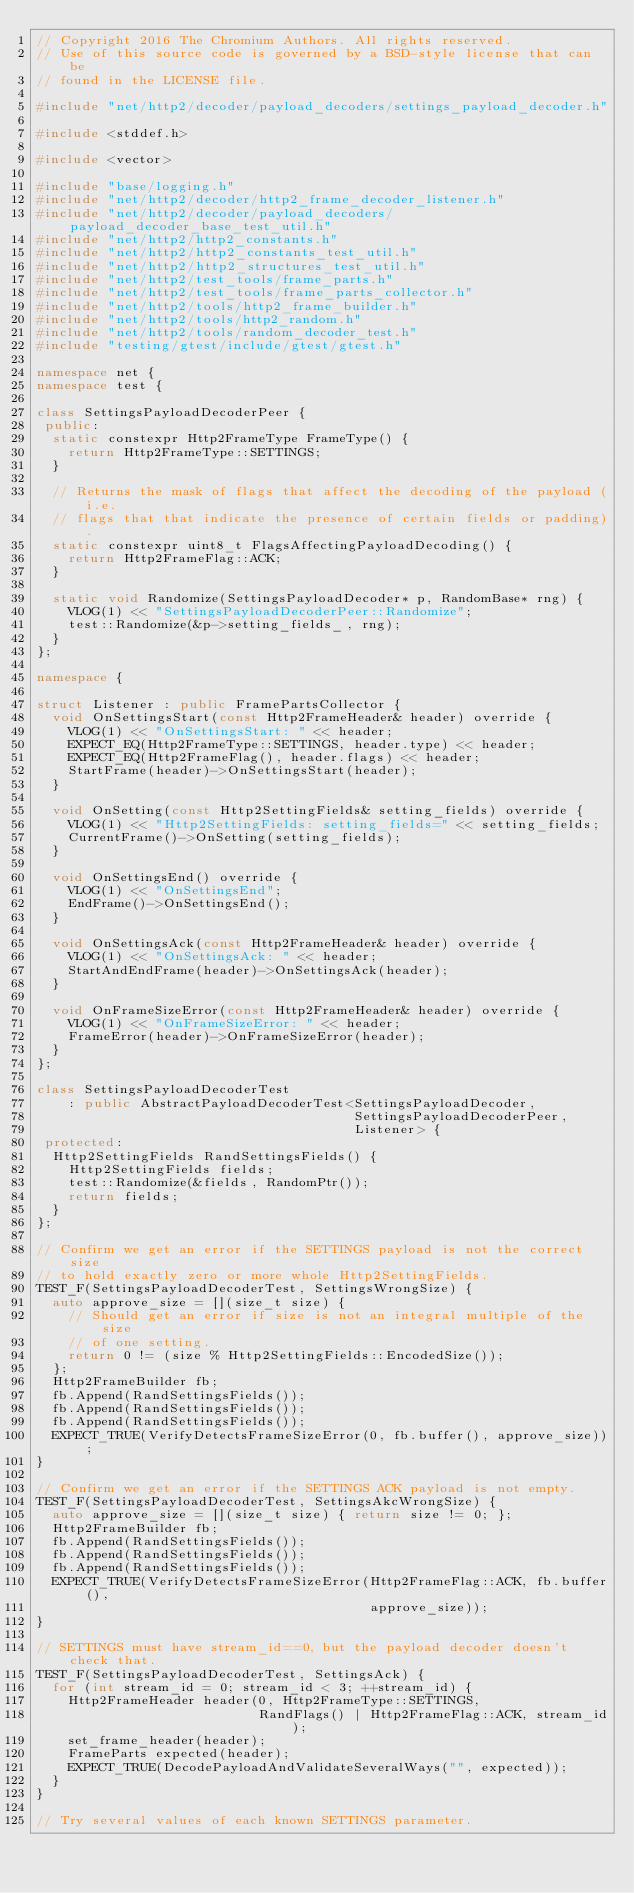<code> <loc_0><loc_0><loc_500><loc_500><_C++_>// Copyright 2016 The Chromium Authors. All rights reserved.
// Use of this source code is governed by a BSD-style license that can be
// found in the LICENSE file.

#include "net/http2/decoder/payload_decoders/settings_payload_decoder.h"

#include <stddef.h>

#include <vector>

#include "base/logging.h"
#include "net/http2/decoder/http2_frame_decoder_listener.h"
#include "net/http2/decoder/payload_decoders/payload_decoder_base_test_util.h"
#include "net/http2/http2_constants.h"
#include "net/http2/http2_constants_test_util.h"
#include "net/http2/http2_structures_test_util.h"
#include "net/http2/test_tools/frame_parts.h"
#include "net/http2/test_tools/frame_parts_collector.h"
#include "net/http2/tools/http2_frame_builder.h"
#include "net/http2/tools/http2_random.h"
#include "net/http2/tools/random_decoder_test.h"
#include "testing/gtest/include/gtest/gtest.h"

namespace net {
namespace test {

class SettingsPayloadDecoderPeer {
 public:
  static constexpr Http2FrameType FrameType() {
    return Http2FrameType::SETTINGS;
  }

  // Returns the mask of flags that affect the decoding of the payload (i.e.
  // flags that that indicate the presence of certain fields or padding).
  static constexpr uint8_t FlagsAffectingPayloadDecoding() {
    return Http2FrameFlag::ACK;
  }

  static void Randomize(SettingsPayloadDecoder* p, RandomBase* rng) {
    VLOG(1) << "SettingsPayloadDecoderPeer::Randomize";
    test::Randomize(&p->setting_fields_, rng);
  }
};

namespace {

struct Listener : public FramePartsCollector {
  void OnSettingsStart(const Http2FrameHeader& header) override {
    VLOG(1) << "OnSettingsStart: " << header;
    EXPECT_EQ(Http2FrameType::SETTINGS, header.type) << header;
    EXPECT_EQ(Http2FrameFlag(), header.flags) << header;
    StartFrame(header)->OnSettingsStart(header);
  }

  void OnSetting(const Http2SettingFields& setting_fields) override {
    VLOG(1) << "Http2SettingFields: setting_fields=" << setting_fields;
    CurrentFrame()->OnSetting(setting_fields);
  }

  void OnSettingsEnd() override {
    VLOG(1) << "OnSettingsEnd";
    EndFrame()->OnSettingsEnd();
  }

  void OnSettingsAck(const Http2FrameHeader& header) override {
    VLOG(1) << "OnSettingsAck: " << header;
    StartAndEndFrame(header)->OnSettingsAck(header);
  }

  void OnFrameSizeError(const Http2FrameHeader& header) override {
    VLOG(1) << "OnFrameSizeError: " << header;
    FrameError(header)->OnFrameSizeError(header);
  }
};

class SettingsPayloadDecoderTest
    : public AbstractPayloadDecoderTest<SettingsPayloadDecoder,
                                        SettingsPayloadDecoderPeer,
                                        Listener> {
 protected:
  Http2SettingFields RandSettingsFields() {
    Http2SettingFields fields;
    test::Randomize(&fields, RandomPtr());
    return fields;
  }
};

// Confirm we get an error if the SETTINGS payload is not the correct size
// to hold exactly zero or more whole Http2SettingFields.
TEST_F(SettingsPayloadDecoderTest, SettingsWrongSize) {
  auto approve_size = [](size_t size) {
    // Should get an error if size is not an integral multiple of the size
    // of one setting.
    return 0 != (size % Http2SettingFields::EncodedSize());
  };
  Http2FrameBuilder fb;
  fb.Append(RandSettingsFields());
  fb.Append(RandSettingsFields());
  fb.Append(RandSettingsFields());
  EXPECT_TRUE(VerifyDetectsFrameSizeError(0, fb.buffer(), approve_size));
}

// Confirm we get an error if the SETTINGS ACK payload is not empty.
TEST_F(SettingsPayloadDecoderTest, SettingsAkcWrongSize) {
  auto approve_size = [](size_t size) { return size != 0; };
  Http2FrameBuilder fb;
  fb.Append(RandSettingsFields());
  fb.Append(RandSettingsFields());
  fb.Append(RandSettingsFields());
  EXPECT_TRUE(VerifyDetectsFrameSizeError(Http2FrameFlag::ACK, fb.buffer(),
                                          approve_size));
}

// SETTINGS must have stream_id==0, but the payload decoder doesn't check that.
TEST_F(SettingsPayloadDecoderTest, SettingsAck) {
  for (int stream_id = 0; stream_id < 3; ++stream_id) {
    Http2FrameHeader header(0, Http2FrameType::SETTINGS,
                            RandFlags() | Http2FrameFlag::ACK, stream_id);
    set_frame_header(header);
    FrameParts expected(header);
    EXPECT_TRUE(DecodePayloadAndValidateSeveralWays("", expected));
  }
}

// Try several values of each known SETTINGS parameter.</code> 